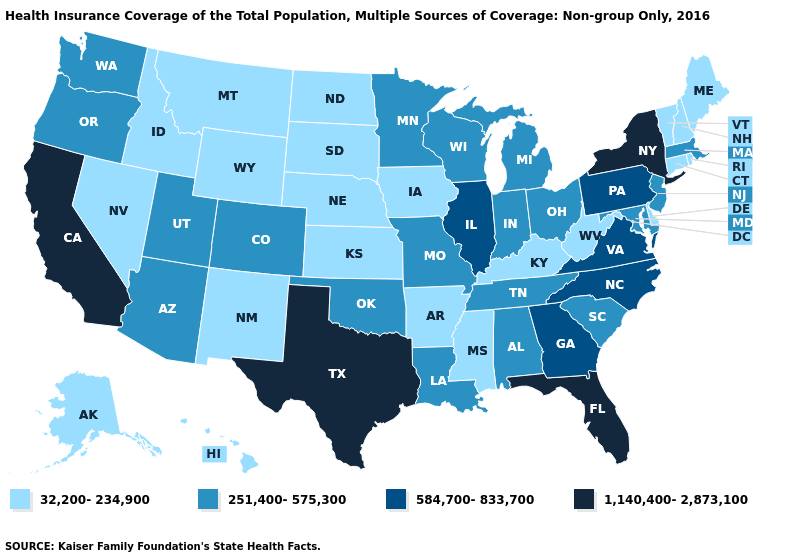What is the value of Idaho?
Quick response, please. 32,200-234,900. Name the states that have a value in the range 32,200-234,900?
Answer briefly. Alaska, Arkansas, Connecticut, Delaware, Hawaii, Idaho, Iowa, Kansas, Kentucky, Maine, Mississippi, Montana, Nebraska, Nevada, New Hampshire, New Mexico, North Dakota, Rhode Island, South Dakota, Vermont, West Virginia, Wyoming. Does Maryland have the same value as Michigan?
Keep it brief. Yes. Which states hav the highest value in the West?
Give a very brief answer. California. Does the map have missing data?
Give a very brief answer. No. Name the states that have a value in the range 1,140,400-2,873,100?
Be succinct. California, Florida, New York, Texas. Name the states that have a value in the range 584,700-833,700?
Give a very brief answer. Georgia, Illinois, North Carolina, Pennsylvania, Virginia. What is the value of Missouri?
Give a very brief answer. 251,400-575,300. Does Georgia have the highest value in the USA?
Short answer required. No. Name the states that have a value in the range 32,200-234,900?
Short answer required. Alaska, Arkansas, Connecticut, Delaware, Hawaii, Idaho, Iowa, Kansas, Kentucky, Maine, Mississippi, Montana, Nebraska, Nevada, New Hampshire, New Mexico, North Dakota, Rhode Island, South Dakota, Vermont, West Virginia, Wyoming. What is the value of Connecticut?
Quick response, please. 32,200-234,900. Among the states that border Florida , which have the lowest value?
Be succinct. Alabama. How many symbols are there in the legend?
Give a very brief answer. 4. What is the value of Arkansas?
Answer briefly. 32,200-234,900. What is the highest value in the USA?
Write a very short answer. 1,140,400-2,873,100. 